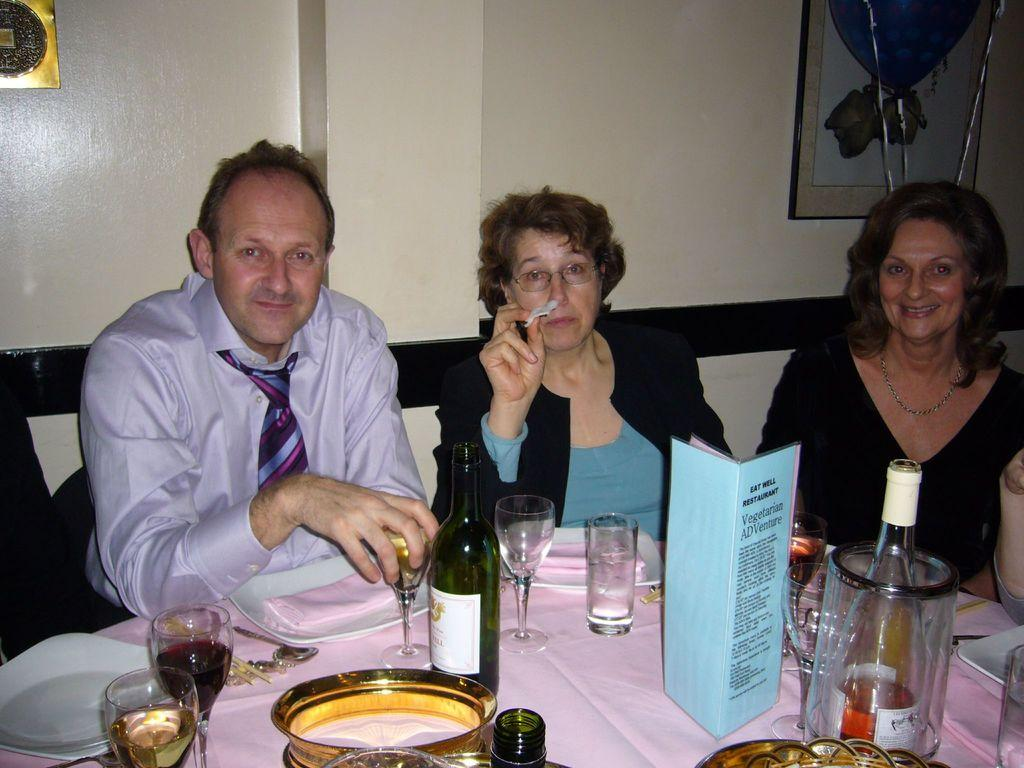What is the man in the image doing? The man is sitting on a chair in the image. What is the man holding in the image? The man is holding a wine glass. How many women are sitting on chairs in the image? There are two women sitting on chairs in the image. What are the women doing in the image? The women are laughing. What other items related to wine can be seen in the image? There are wine bottles and wine glasses in the image. What is present on the dining table in the image? There are plates on the dining table in the image. What type of steel is used to support the plane in the image? There is no plane present in the image, and therefore no steel support can be observed. 